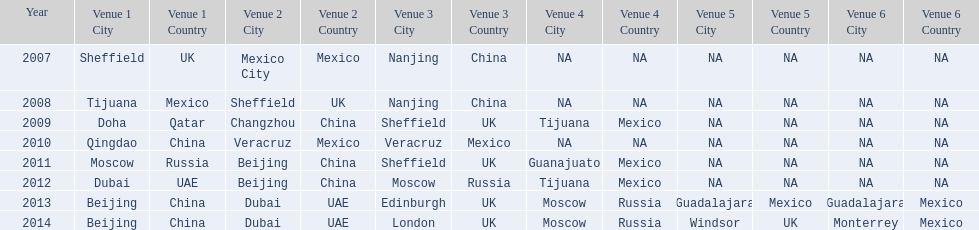Which two venue has no nations from 2007-2012 5th Venue, 6th Venue. 